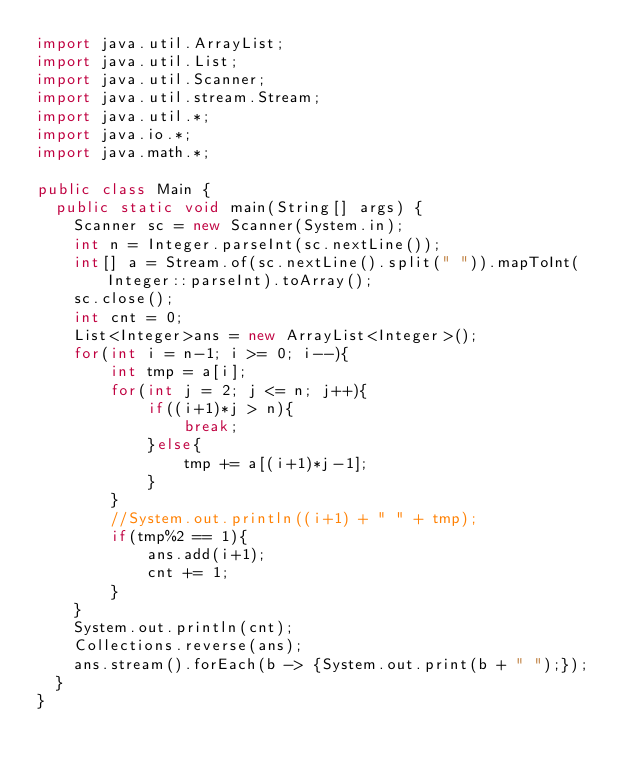<code> <loc_0><loc_0><loc_500><loc_500><_Java_>import java.util.ArrayList;
import java.util.List;
import java.util.Scanner;
import java.util.stream.Stream;
import java.util.*;
import java.io.*;
import java.math.*;
 
public class Main {
  public static void main(String[] args) {
    Scanner sc = new Scanner(System.in);
    int n = Integer.parseInt(sc.nextLine());
    int[] a = Stream.of(sc.nextLine().split(" ")).mapToInt(Integer::parseInt).toArray();
    sc.close();
    int cnt = 0;
    List<Integer>ans = new ArrayList<Integer>();
    for(int i = n-1; i >= 0; i--){
        int tmp = a[i];
        for(int j = 2; j <= n; j++){
            if((i+1)*j > n){
                break;
            }else{
                tmp += a[(i+1)*j-1];
            }
        }
        //System.out.println((i+1) + " " + tmp);
        if(tmp%2 == 1){
            ans.add(i+1);
            cnt += 1;
        }
    }
    System.out.println(cnt);
    Collections.reverse(ans);
    ans.stream().forEach(b -> {System.out.print(b + " ");});
  }
}</code> 